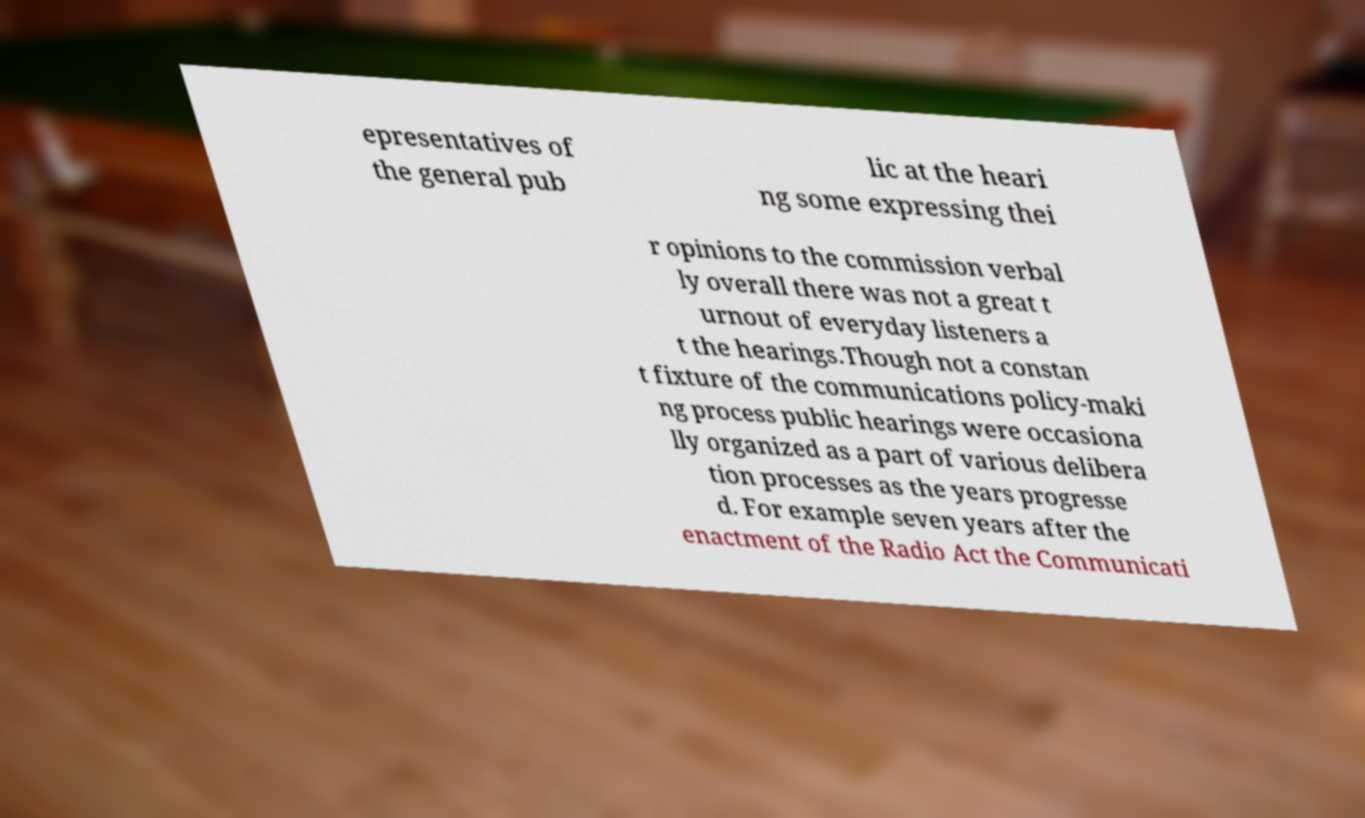For documentation purposes, I need the text within this image transcribed. Could you provide that? epresentatives of the general pub lic at the heari ng some expressing thei r opinions to the commission verbal ly overall there was not a great t urnout of everyday listeners a t the hearings.Though not a constan t fixture of the communications policy-maki ng process public hearings were occasiona lly organized as a part of various delibera tion processes as the years progresse d. For example seven years after the enactment of the Radio Act the Communicati 